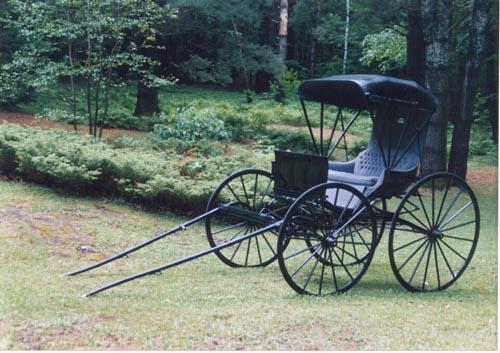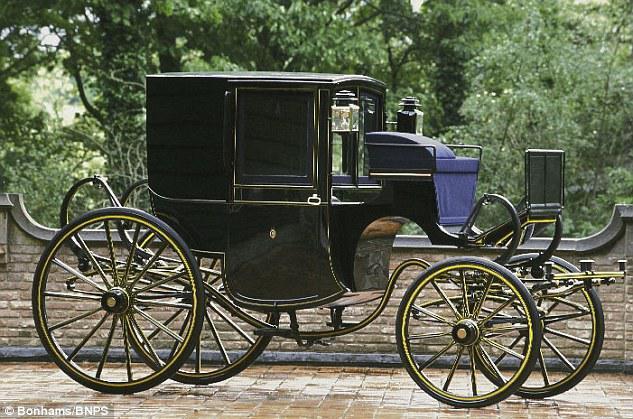The first image is the image on the left, the second image is the image on the right. Analyze the images presented: Is the assertion "An image features a four-wheeled cart with distinctly smaller wheels at the front." valid? Answer yes or no. Yes. The first image is the image on the left, the second image is the image on the right. For the images displayed, is the sentence "The front leads of the carriage are resting on the ground in one of the images." factually correct? Answer yes or no. Yes. 